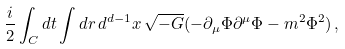Convert formula to latex. <formula><loc_0><loc_0><loc_500><loc_500>\frac { i } { 2 } \int _ { C } d t \int d r \, d ^ { d - 1 } x \, \sqrt { - G } ( - \partial _ { \mu } \Phi \partial ^ { \mu } \Phi - m ^ { 2 } \Phi ^ { 2 } ) \, ,</formula> 